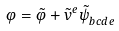<formula> <loc_0><loc_0><loc_500><loc_500>\varphi = \tilde { \varphi } + \tilde { v } ^ { e } \tilde { \psi } _ { b c d e } ^ { \quad \ \ }</formula> 